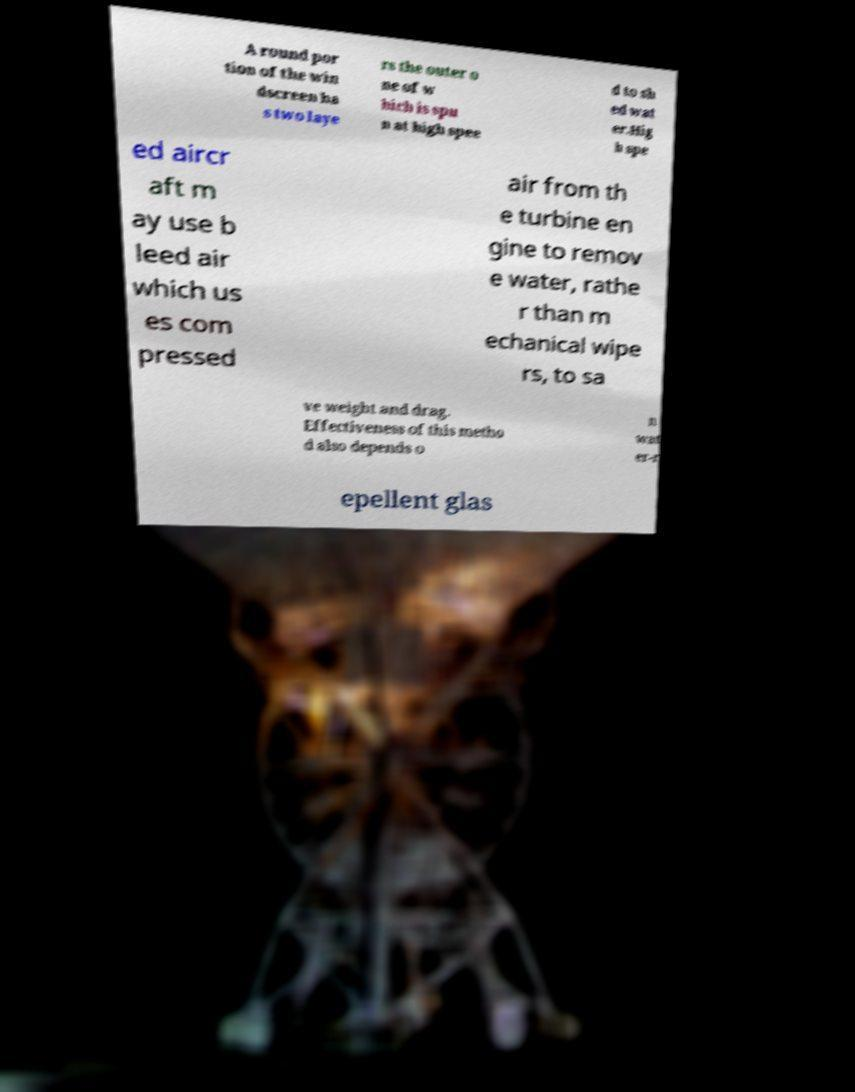I need the written content from this picture converted into text. Can you do that? A round por tion of the win dscreen ha s two laye rs the outer o ne of w hich is spu n at high spee d to sh ed wat er.Hig h spe ed aircr aft m ay use b leed air which us es com pressed air from th e turbine en gine to remov e water, rathe r than m echanical wipe rs, to sa ve weight and drag. Effectiveness of this metho d also depends o n wat er-r epellent glas 